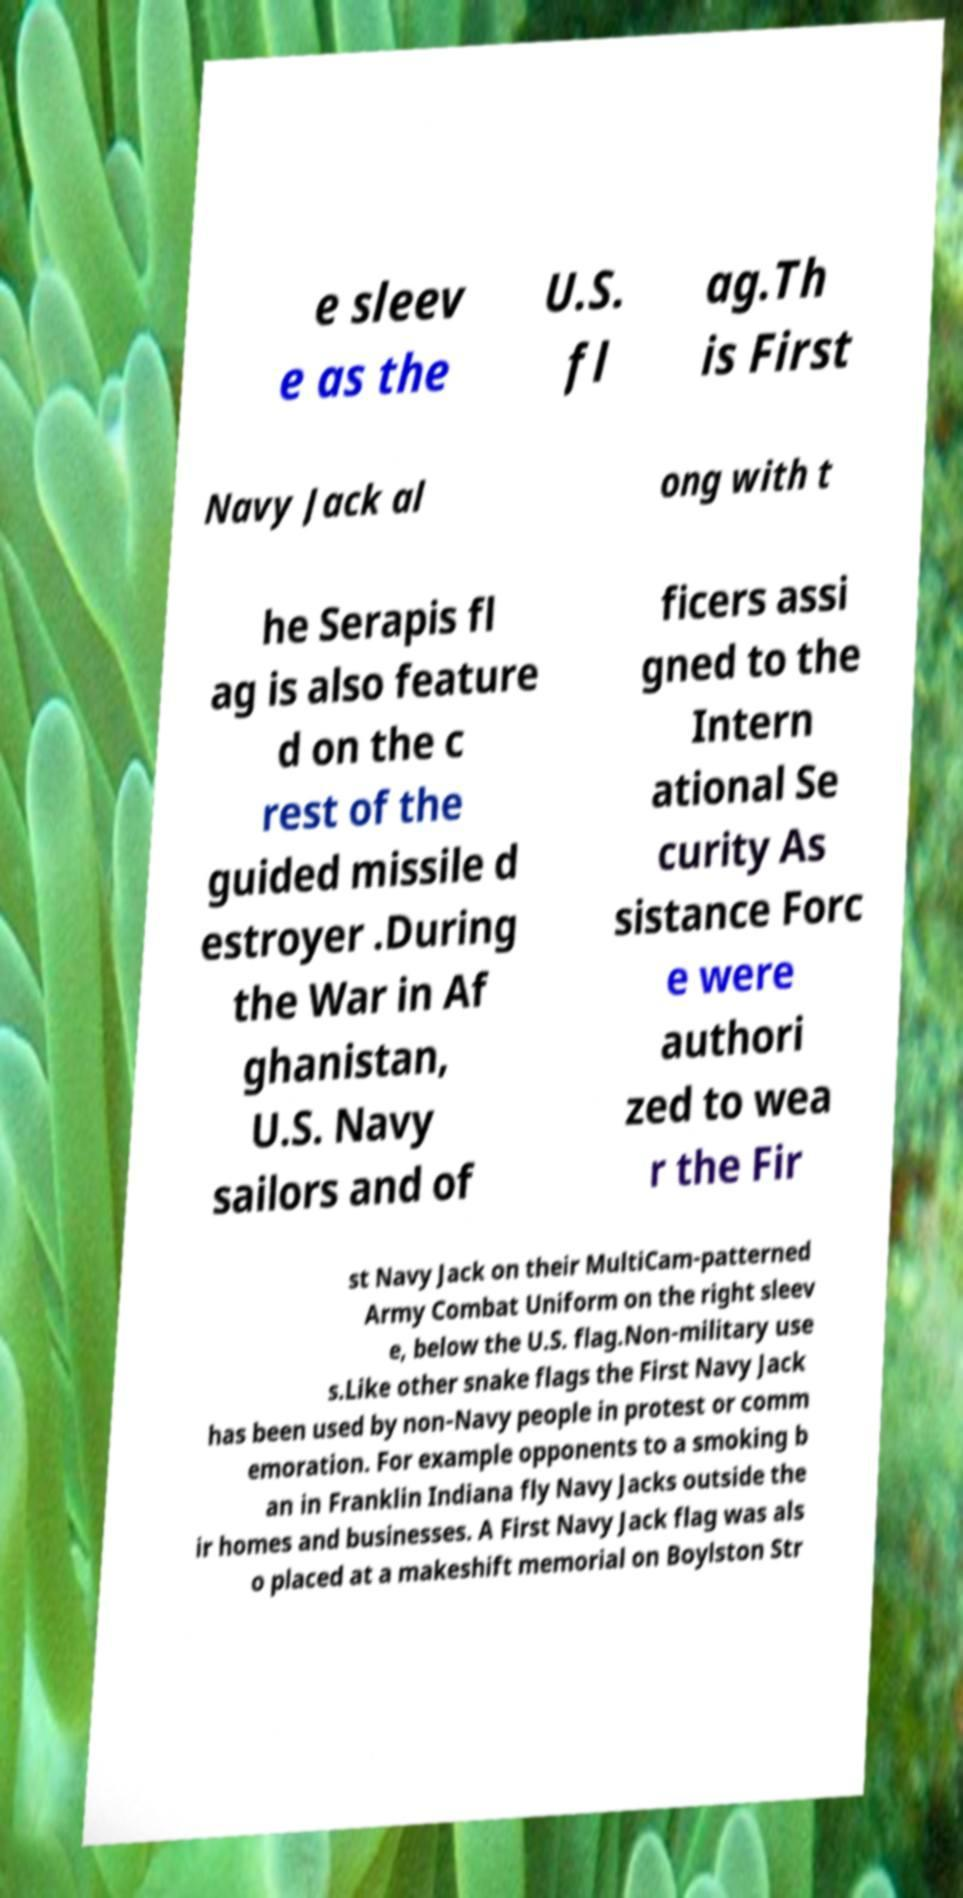Could you assist in decoding the text presented in this image and type it out clearly? e sleev e as the U.S. fl ag.Th is First Navy Jack al ong with t he Serapis fl ag is also feature d on the c rest of the guided missile d estroyer .During the War in Af ghanistan, U.S. Navy sailors and of ficers assi gned to the Intern ational Se curity As sistance Forc e were authori zed to wea r the Fir st Navy Jack on their MultiCam-patterned Army Combat Uniform on the right sleev e, below the U.S. flag.Non-military use s.Like other snake flags the First Navy Jack has been used by non-Navy people in protest or comm emoration. For example opponents to a smoking b an in Franklin Indiana fly Navy Jacks outside the ir homes and businesses. A First Navy Jack flag was als o placed at a makeshift memorial on Boylston Str 